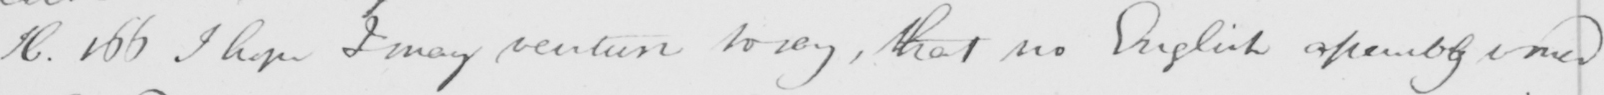Please transcribe the handwritten text in this image. H . 166 I hope I may venture to say , that no English assembly need 